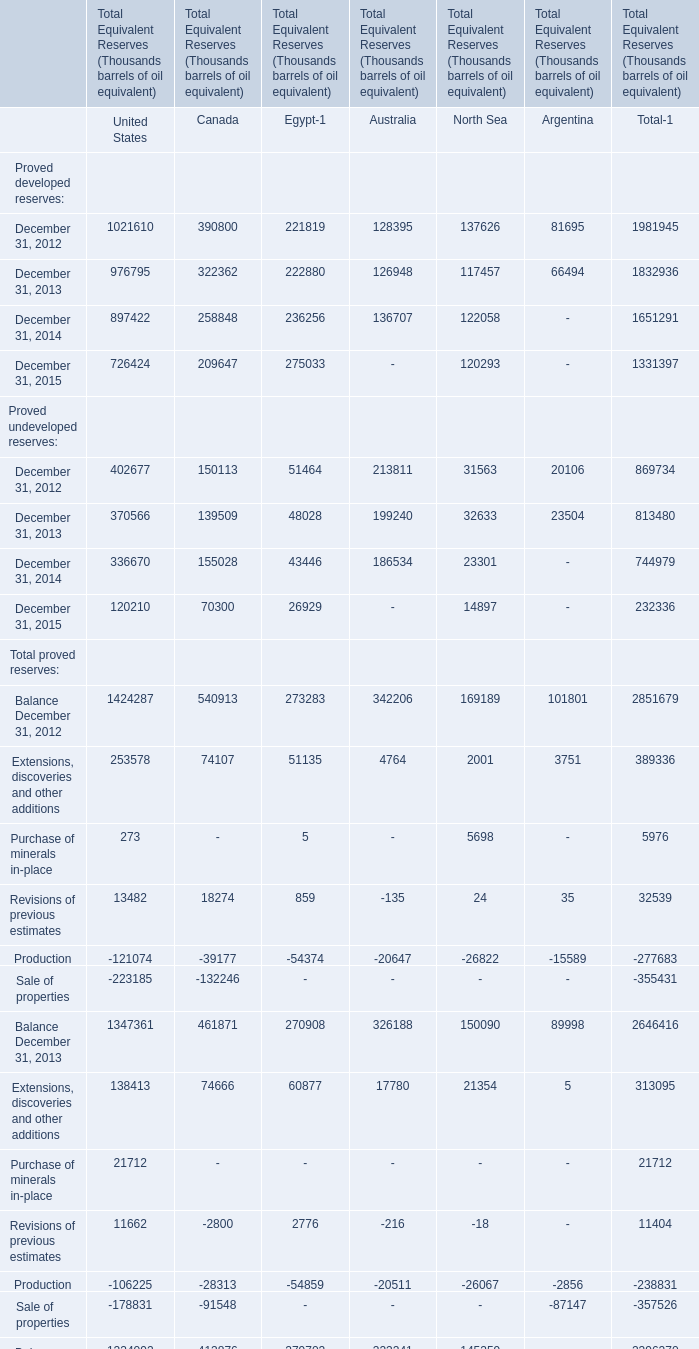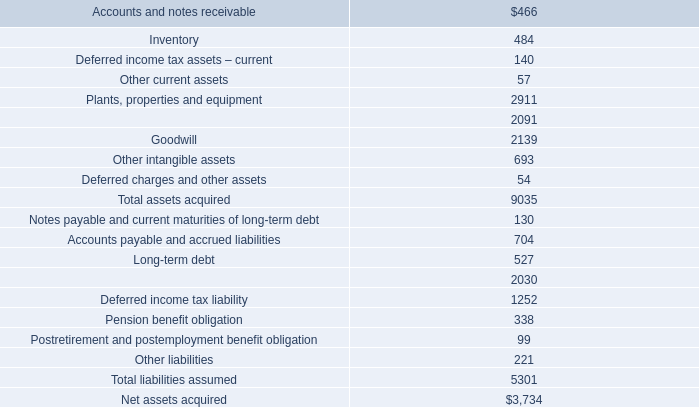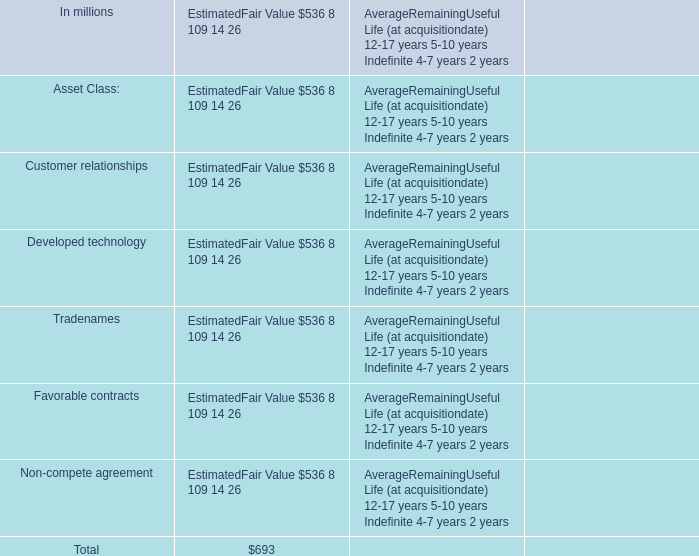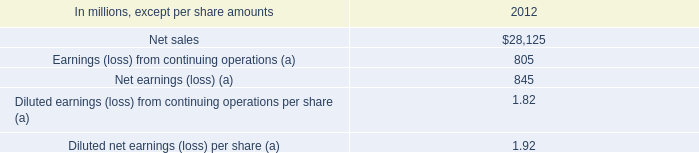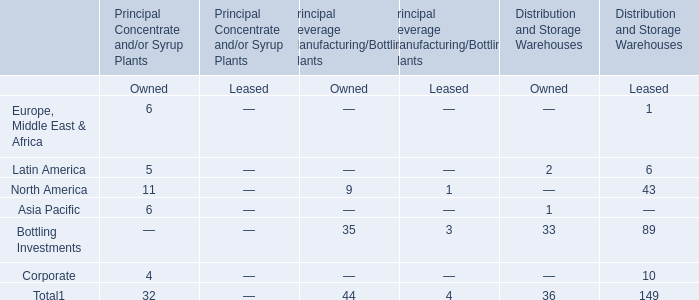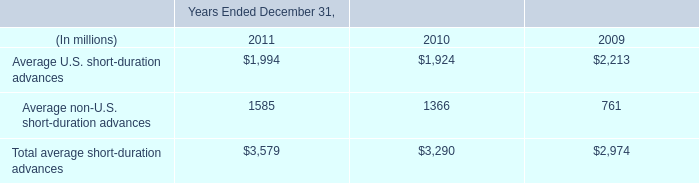What's the sum of Proved developed reserves in 2012? (in Thousand) 
Answer: 1981945. 